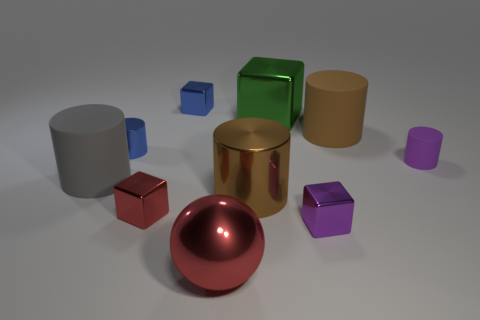Are there any other things that are the same color as the large ball?
Your response must be concise. Yes. There is a big metal ball; is its color the same as the block left of the tiny blue block?
Your answer should be compact. Yes. Do the large matte cylinder right of the tiny purple block and the large shiny cylinder have the same color?
Keep it short and to the point. Yes. Is the big gray cylinder made of the same material as the red block?
Make the answer very short. No. There is a block that is both in front of the big metallic block and to the left of the large ball; what color is it?
Your answer should be very brief. Red. Is there a metal ball of the same size as the brown rubber thing?
Your response must be concise. Yes. What is the size of the matte cylinder that is right of the large rubber cylinder that is on the right side of the red ball?
Keep it short and to the point. Small. Is the number of gray objects on the left side of the tiny red block less than the number of cylinders?
Give a very brief answer. Yes. How big is the shiny sphere?
Make the answer very short. Large. How many tiny metallic objects are the same color as the tiny rubber thing?
Make the answer very short. 1. 